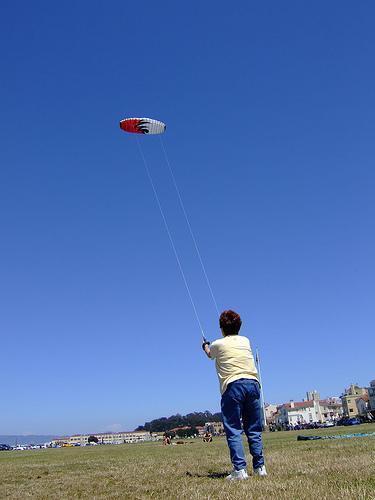How many people are flying a kite?
Give a very brief answer. 1. 